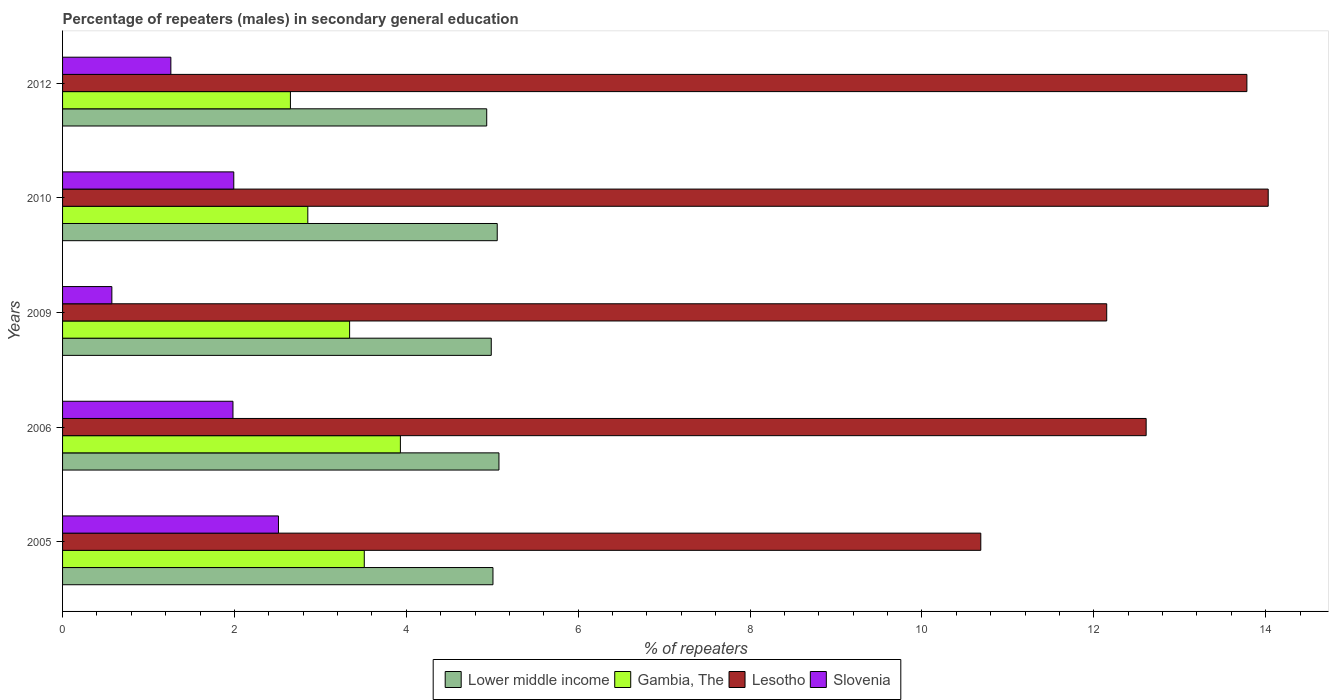How many different coloured bars are there?
Keep it short and to the point. 4. How many groups of bars are there?
Offer a very short reply. 5. Are the number of bars per tick equal to the number of legend labels?
Your answer should be compact. Yes. How many bars are there on the 2nd tick from the bottom?
Your answer should be very brief. 4. What is the label of the 4th group of bars from the top?
Make the answer very short. 2006. In how many cases, is the number of bars for a given year not equal to the number of legend labels?
Your answer should be very brief. 0. What is the percentage of male repeaters in Lesotho in 2006?
Your response must be concise. 12.61. Across all years, what is the maximum percentage of male repeaters in Gambia, The?
Ensure brevity in your answer.  3.93. Across all years, what is the minimum percentage of male repeaters in Lesotho?
Ensure brevity in your answer.  10.68. In which year was the percentage of male repeaters in Lower middle income minimum?
Keep it short and to the point. 2012. What is the total percentage of male repeaters in Lesotho in the graph?
Give a very brief answer. 63.25. What is the difference between the percentage of male repeaters in Lower middle income in 2005 and that in 2010?
Offer a terse response. -0.05. What is the difference between the percentage of male repeaters in Lesotho in 2006 and the percentage of male repeaters in Slovenia in 2009?
Provide a short and direct response. 12.04. What is the average percentage of male repeaters in Gambia, The per year?
Offer a very short reply. 3.26. In the year 2012, what is the difference between the percentage of male repeaters in Slovenia and percentage of male repeaters in Lesotho?
Keep it short and to the point. -12.52. In how many years, is the percentage of male repeaters in Gambia, The greater than 6 %?
Keep it short and to the point. 0. What is the ratio of the percentage of male repeaters in Gambia, The in 2005 to that in 2010?
Ensure brevity in your answer.  1.23. Is the percentage of male repeaters in Gambia, The in 2010 less than that in 2012?
Keep it short and to the point. No. What is the difference between the highest and the second highest percentage of male repeaters in Lesotho?
Provide a succinct answer. 0.25. What is the difference between the highest and the lowest percentage of male repeaters in Gambia, The?
Offer a very short reply. 1.28. In how many years, is the percentage of male repeaters in Gambia, The greater than the average percentage of male repeaters in Gambia, The taken over all years?
Offer a terse response. 3. Is it the case that in every year, the sum of the percentage of male repeaters in Lesotho and percentage of male repeaters in Slovenia is greater than the sum of percentage of male repeaters in Lower middle income and percentage of male repeaters in Gambia, The?
Offer a very short reply. No. What does the 4th bar from the top in 2010 represents?
Ensure brevity in your answer.  Lower middle income. What does the 3rd bar from the bottom in 2010 represents?
Provide a short and direct response. Lesotho. How many bars are there?
Your answer should be very brief. 20. Are all the bars in the graph horizontal?
Give a very brief answer. Yes. How many years are there in the graph?
Offer a terse response. 5. What is the difference between two consecutive major ticks on the X-axis?
Provide a short and direct response. 2. Does the graph contain any zero values?
Offer a terse response. No. Where does the legend appear in the graph?
Provide a short and direct response. Bottom center. How are the legend labels stacked?
Provide a succinct answer. Horizontal. What is the title of the graph?
Provide a short and direct response. Percentage of repeaters (males) in secondary general education. What is the label or title of the X-axis?
Provide a short and direct response. % of repeaters. What is the % of repeaters of Lower middle income in 2005?
Your answer should be very brief. 5.01. What is the % of repeaters in Gambia, The in 2005?
Offer a terse response. 3.51. What is the % of repeaters in Lesotho in 2005?
Your answer should be compact. 10.68. What is the % of repeaters in Slovenia in 2005?
Keep it short and to the point. 2.51. What is the % of repeaters in Lower middle income in 2006?
Your answer should be compact. 5.08. What is the % of repeaters in Gambia, The in 2006?
Give a very brief answer. 3.93. What is the % of repeaters of Lesotho in 2006?
Offer a very short reply. 12.61. What is the % of repeaters in Slovenia in 2006?
Provide a short and direct response. 1.98. What is the % of repeaters of Lower middle income in 2009?
Provide a succinct answer. 4.99. What is the % of repeaters in Gambia, The in 2009?
Ensure brevity in your answer.  3.34. What is the % of repeaters of Lesotho in 2009?
Offer a terse response. 12.15. What is the % of repeaters of Slovenia in 2009?
Offer a terse response. 0.57. What is the % of repeaters of Lower middle income in 2010?
Ensure brevity in your answer.  5.06. What is the % of repeaters in Gambia, The in 2010?
Give a very brief answer. 2.85. What is the % of repeaters of Lesotho in 2010?
Offer a terse response. 14.03. What is the % of repeaters in Slovenia in 2010?
Keep it short and to the point. 1.99. What is the % of repeaters of Lower middle income in 2012?
Your answer should be very brief. 4.94. What is the % of repeaters of Gambia, The in 2012?
Offer a very short reply. 2.65. What is the % of repeaters in Lesotho in 2012?
Provide a succinct answer. 13.78. What is the % of repeaters in Slovenia in 2012?
Offer a terse response. 1.26. Across all years, what is the maximum % of repeaters of Lower middle income?
Give a very brief answer. 5.08. Across all years, what is the maximum % of repeaters in Gambia, The?
Your answer should be compact. 3.93. Across all years, what is the maximum % of repeaters of Lesotho?
Your answer should be very brief. 14.03. Across all years, what is the maximum % of repeaters of Slovenia?
Your answer should be compact. 2.51. Across all years, what is the minimum % of repeaters in Lower middle income?
Keep it short and to the point. 4.94. Across all years, what is the minimum % of repeaters of Gambia, The?
Your answer should be compact. 2.65. Across all years, what is the minimum % of repeaters in Lesotho?
Provide a short and direct response. 10.68. Across all years, what is the minimum % of repeaters of Slovenia?
Your answer should be very brief. 0.57. What is the total % of repeaters in Lower middle income in the graph?
Offer a very short reply. 25.07. What is the total % of repeaters of Gambia, The in the graph?
Ensure brevity in your answer.  16.29. What is the total % of repeaters of Lesotho in the graph?
Ensure brevity in your answer.  63.25. What is the total % of repeaters of Slovenia in the graph?
Provide a short and direct response. 8.32. What is the difference between the % of repeaters of Lower middle income in 2005 and that in 2006?
Offer a terse response. -0.07. What is the difference between the % of repeaters of Gambia, The in 2005 and that in 2006?
Provide a succinct answer. -0.42. What is the difference between the % of repeaters of Lesotho in 2005 and that in 2006?
Keep it short and to the point. -1.92. What is the difference between the % of repeaters of Slovenia in 2005 and that in 2006?
Keep it short and to the point. 0.53. What is the difference between the % of repeaters of Lower middle income in 2005 and that in 2009?
Offer a very short reply. 0.02. What is the difference between the % of repeaters in Gambia, The in 2005 and that in 2009?
Your answer should be compact. 0.17. What is the difference between the % of repeaters of Lesotho in 2005 and that in 2009?
Your response must be concise. -1.47. What is the difference between the % of repeaters in Slovenia in 2005 and that in 2009?
Your answer should be very brief. 1.94. What is the difference between the % of repeaters in Lower middle income in 2005 and that in 2010?
Your response must be concise. -0.05. What is the difference between the % of repeaters in Gambia, The in 2005 and that in 2010?
Make the answer very short. 0.66. What is the difference between the % of repeaters of Lesotho in 2005 and that in 2010?
Keep it short and to the point. -3.34. What is the difference between the % of repeaters in Slovenia in 2005 and that in 2010?
Keep it short and to the point. 0.52. What is the difference between the % of repeaters in Lower middle income in 2005 and that in 2012?
Offer a very short reply. 0.07. What is the difference between the % of repeaters of Gambia, The in 2005 and that in 2012?
Provide a succinct answer. 0.86. What is the difference between the % of repeaters of Lesotho in 2005 and that in 2012?
Your answer should be compact. -3.1. What is the difference between the % of repeaters of Slovenia in 2005 and that in 2012?
Your answer should be compact. 1.25. What is the difference between the % of repeaters of Lower middle income in 2006 and that in 2009?
Ensure brevity in your answer.  0.09. What is the difference between the % of repeaters of Gambia, The in 2006 and that in 2009?
Provide a short and direct response. 0.59. What is the difference between the % of repeaters of Lesotho in 2006 and that in 2009?
Make the answer very short. 0.46. What is the difference between the % of repeaters of Slovenia in 2006 and that in 2009?
Ensure brevity in your answer.  1.41. What is the difference between the % of repeaters in Lower middle income in 2006 and that in 2010?
Provide a succinct answer. 0.02. What is the difference between the % of repeaters of Gambia, The in 2006 and that in 2010?
Keep it short and to the point. 1.08. What is the difference between the % of repeaters of Lesotho in 2006 and that in 2010?
Give a very brief answer. -1.42. What is the difference between the % of repeaters of Slovenia in 2006 and that in 2010?
Make the answer very short. -0.01. What is the difference between the % of repeaters in Lower middle income in 2006 and that in 2012?
Your answer should be very brief. 0.14. What is the difference between the % of repeaters of Gambia, The in 2006 and that in 2012?
Make the answer very short. 1.28. What is the difference between the % of repeaters of Lesotho in 2006 and that in 2012?
Offer a terse response. -1.17. What is the difference between the % of repeaters in Slovenia in 2006 and that in 2012?
Offer a terse response. 0.72. What is the difference between the % of repeaters in Lower middle income in 2009 and that in 2010?
Offer a very short reply. -0.07. What is the difference between the % of repeaters in Gambia, The in 2009 and that in 2010?
Provide a short and direct response. 0.49. What is the difference between the % of repeaters in Lesotho in 2009 and that in 2010?
Make the answer very short. -1.88. What is the difference between the % of repeaters in Slovenia in 2009 and that in 2010?
Your answer should be very brief. -1.42. What is the difference between the % of repeaters of Lower middle income in 2009 and that in 2012?
Your answer should be very brief. 0.05. What is the difference between the % of repeaters in Gambia, The in 2009 and that in 2012?
Keep it short and to the point. 0.69. What is the difference between the % of repeaters of Lesotho in 2009 and that in 2012?
Your response must be concise. -1.63. What is the difference between the % of repeaters in Slovenia in 2009 and that in 2012?
Make the answer very short. -0.69. What is the difference between the % of repeaters of Lower middle income in 2010 and that in 2012?
Give a very brief answer. 0.12. What is the difference between the % of repeaters of Gambia, The in 2010 and that in 2012?
Offer a very short reply. 0.2. What is the difference between the % of repeaters in Lesotho in 2010 and that in 2012?
Keep it short and to the point. 0.25. What is the difference between the % of repeaters in Slovenia in 2010 and that in 2012?
Provide a succinct answer. 0.73. What is the difference between the % of repeaters of Lower middle income in 2005 and the % of repeaters of Gambia, The in 2006?
Make the answer very short. 1.08. What is the difference between the % of repeaters in Lower middle income in 2005 and the % of repeaters in Lesotho in 2006?
Your answer should be compact. -7.6. What is the difference between the % of repeaters in Lower middle income in 2005 and the % of repeaters in Slovenia in 2006?
Offer a very short reply. 3.03. What is the difference between the % of repeaters in Gambia, The in 2005 and the % of repeaters in Lesotho in 2006?
Give a very brief answer. -9.1. What is the difference between the % of repeaters in Gambia, The in 2005 and the % of repeaters in Slovenia in 2006?
Your response must be concise. 1.53. What is the difference between the % of repeaters in Lesotho in 2005 and the % of repeaters in Slovenia in 2006?
Ensure brevity in your answer.  8.7. What is the difference between the % of repeaters of Lower middle income in 2005 and the % of repeaters of Gambia, The in 2009?
Give a very brief answer. 1.67. What is the difference between the % of repeaters of Lower middle income in 2005 and the % of repeaters of Lesotho in 2009?
Your response must be concise. -7.14. What is the difference between the % of repeaters in Lower middle income in 2005 and the % of repeaters in Slovenia in 2009?
Your answer should be very brief. 4.43. What is the difference between the % of repeaters in Gambia, The in 2005 and the % of repeaters in Lesotho in 2009?
Provide a succinct answer. -8.64. What is the difference between the % of repeaters in Gambia, The in 2005 and the % of repeaters in Slovenia in 2009?
Provide a succinct answer. 2.94. What is the difference between the % of repeaters in Lesotho in 2005 and the % of repeaters in Slovenia in 2009?
Your answer should be very brief. 10.11. What is the difference between the % of repeaters of Lower middle income in 2005 and the % of repeaters of Gambia, The in 2010?
Your response must be concise. 2.15. What is the difference between the % of repeaters in Lower middle income in 2005 and the % of repeaters in Lesotho in 2010?
Your response must be concise. -9.02. What is the difference between the % of repeaters in Lower middle income in 2005 and the % of repeaters in Slovenia in 2010?
Offer a very short reply. 3.02. What is the difference between the % of repeaters in Gambia, The in 2005 and the % of repeaters in Lesotho in 2010?
Offer a terse response. -10.52. What is the difference between the % of repeaters of Gambia, The in 2005 and the % of repeaters of Slovenia in 2010?
Your answer should be compact. 1.52. What is the difference between the % of repeaters in Lesotho in 2005 and the % of repeaters in Slovenia in 2010?
Your response must be concise. 8.69. What is the difference between the % of repeaters of Lower middle income in 2005 and the % of repeaters of Gambia, The in 2012?
Ensure brevity in your answer.  2.36. What is the difference between the % of repeaters of Lower middle income in 2005 and the % of repeaters of Lesotho in 2012?
Offer a terse response. -8.77. What is the difference between the % of repeaters of Lower middle income in 2005 and the % of repeaters of Slovenia in 2012?
Give a very brief answer. 3.75. What is the difference between the % of repeaters in Gambia, The in 2005 and the % of repeaters in Lesotho in 2012?
Provide a succinct answer. -10.27. What is the difference between the % of repeaters in Gambia, The in 2005 and the % of repeaters in Slovenia in 2012?
Your answer should be compact. 2.25. What is the difference between the % of repeaters in Lesotho in 2005 and the % of repeaters in Slovenia in 2012?
Offer a terse response. 9.42. What is the difference between the % of repeaters of Lower middle income in 2006 and the % of repeaters of Gambia, The in 2009?
Keep it short and to the point. 1.74. What is the difference between the % of repeaters of Lower middle income in 2006 and the % of repeaters of Lesotho in 2009?
Offer a very short reply. -7.07. What is the difference between the % of repeaters in Lower middle income in 2006 and the % of repeaters in Slovenia in 2009?
Offer a very short reply. 4.5. What is the difference between the % of repeaters of Gambia, The in 2006 and the % of repeaters of Lesotho in 2009?
Offer a terse response. -8.22. What is the difference between the % of repeaters of Gambia, The in 2006 and the % of repeaters of Slovenia in 2009?
Provide a succinct answer. 3.36. What is the difference between the % of repeaters of Lesotho in 2006 and the % of repeaters of Slovenia in 2009?
Make the answer very short. 12.04. What is the difference between the % of repeaters in Lower middle income in 2006 and the % of repeaters in Gambia, The in 2010?
Keep it short and to the point. 2.22. What is the difference between the % of repeaters in Lower middle income in 2006 and the % of repeaters in Lesotho in 2010?
Offer a very short reply. -8.95. What is the difference between the % of repeaters of Lower middle income in 2006 and the % of repeaters of Slovenia in 2010?
Give a very brief answer. 3.09. What is the difference between the % of repeaters of Gambia, The in 2006 and the % of repeaters of Lesotho in 2010?
Keep it short and to the point. -10.1. What is the difference between the % of repeaters of Gambia, The in 2006 and the % of repeaters of Slovenia in 2010?
Give a very brief answer. 1.94. What is the difference between the % of repeaters of Lesotho in 2006 and the % of repeaters of Slovenia in 2010?
Your answer should be very brief. 10.62. What is the difference between the % of repeaters in Lower middle income in 2006 and the % of repeaters in Gambia, The in 2012?
Offer a very short reply. 2.43. What is the difference between the % of repeaters in Lower middle income in 2006 and the % of repeaters in Lesotho in 2012?
Provide a succinct answer. -8.7. What is the difference between the % of repeaters in Lower middle income in 2006 and the % of repeaters in Slovenia in 2012?
Your answer should be very brief. 3.82. What is the difference between the % of repeaters in Gambia, The in 2006 and the % of repeaters in Lesotho in 2012?
Provide a short and direct response. -9.85. What is the difference between the % of repeaters of Gambia, The in 2006 and the % of repeaters of Slovenia in 2012?
Provide a succinct answer. 2.67. What is the difference between the % of repeaters of Lesotho in 2006 and the % of repeaters of Slovenia in 2012?
Your answer should be very brief. 11.35. What is the difference between the % of repeaters in Lower middle income in 2009 and the % of repeaters in Gambia, The in 2010?
Offer a very short reply. 2.13. What is the difference between the % of repeaters in Lower middle income in 2009 and the % of repeaters in Lesotho in 2010?
Offer a very short reply. -9.04. What is the difference between the % of repeaters in Lower middle income in 2009 and the % of repeaters in Slovenia in 2010?
Give a very brief answer. 3. What is the difference between the % of repeaters of Gambia, The in 2009 and the % of repeaters of Lesotho in 2010?
Make the answer very short. -10.69. What is the difference between the % of repeaters in Gambia, The in 2009 and the % of repeaters in Slovenia in 2010?
Your answer should be compact. 1.35. What is the difference between the % of repeaters in Lesotho in 2009 and the % of repeaters in Slovenia in 2010?
Provide a short and direct response. 10.16. What is the difference between the % of repeaters of Lower middle income in 2009 and the % of repeaters of Gambia, The in 2012?
Your answer should be compact. 2.34. What is the difference between the % of repeaters in Lower middle income in 2009 and the % of repeaters in Lesotho in 2012?
Your answer should be compact. -8.79. What is the difference between the % of repeaters of Lower middle income in 2009 and the % of repeaters of Slovenia in 2012?
Offer a very short reply. 3.73. What is the difference between the % of repeaters of Gambia, The in 2009 and the % of repeaters of Lesotho in 2012?
Offer a terse response. -10.44. What is the difference between the % of repeaters of Gambia, The in 2009 and the % of repeaters of Slovenia in 2012?
Keep it short and to the point. 2.08. What is the difference between the % of repeaters of Lesotho in 2009 and the % of repeaters of Slovenia in 2012?
Give a very brief answer. 10.89. What is the difference between the % of repeaters of Lower middle income in 2010 and the % of repeaters of Gambia, The in 2012?
Make the answer very short. 2.41. What is the difference between the % of repeaters of Lower middle income in 2010 and the % of repeaters of Lesotho in 2012?
Make the answer very short. -8.72. What is the difference between the % of repeaters in Lower middle income in 2010 and the % of repeaters in Slovenia in 2012?
Make the answer very short. 3.8. What is the difference between the % of repeaters in Gambia, The in 2010 and the % of repeaters in Lesotho in 2012?
Give a very brief answer. -10.93. What is the difference between the % of repeaters in Gambia, The in 2010 and the % of repeaters in Slovenia in 2012?
Offer a very short reply. 1.59. What is the difference between the % of repeaters of Lesotho in 2010 and the % of repeaters of Slovenia in 2012?
Offer a terse response. 12.77. What is the average % of repeaters of Lower middle income per year?
Ensure brevity in your answer.  5.01. What is the average % of repeaters of Gambia, The per year?
Your answer should be compact. 3.26. What is the average % of repeaters in Lesotho per year?
Offer a terse response. 12.65. What is the average % of repeaters in Slovenia per year?
Make the answer very short. 1.66. In the year 2005, what is the difference between the % of repeaters of Lower middle income and % of repeaters of Gambia, The?
Give a very brief answer. 1.5. In the year 2005, what is the difference between the % of repeaters of Lower middle income and % of repeaters of Lesotho?
Provide a short and direct response. -5.68. In the year 2005, what is the difference between the % of repeaters in Lower middle income and % of repeaters in Slovenia?
Offer a terse response. 2.5. In the year 2005, what is the difference between the % of repeaters in Gambia, The and % of repeaters in Lesotho?
Your answer should be compact. -7.17. In the year 2005, what is the difference between the % of repeaters in Gambia, The and % of repeaters in Slovenia?
Your response must be concise. 1. In the year 2005, what is the difference between the % of repeaters in Lesotho and % of repeaters in Slovenia?
Your response must be concise. 8.17. In the year 2006, what is the difference between the % of repeaters in Lower middle income and % of repeaters in Gambia, The?
Ensure brevity in your answer.  1.15. In the year 2006, what is the difference between the % of repeaters in Lower middle income and % of repeaters in Lesotho?
Provide a succinct answer. -7.53. In the year 2006, what is the difference between the % of repeaters of Lower middle income and % of repeaters of Slovenia?
Give a very brief answer. 3.1. In the year 2006, what is the difference between the % of repeaters in Gambia, The and % of repeaters in Lesotho?
Your answer should be very brief. -8.68. In the year 2006, what is the difference between the % of repeaters in Gambia, The and % of repeaters in Slovenia?
Provide a short and direct response. 1.95. In the year 2006, what is the difference between the % of repeaters in Lesotho and % of repeaters in Slovenia?
Offer a very short reply. 10.63. In the year 2009, what is the difference between the % of repeaters of Lower middle income and % of repeaters of Gambia, The?
Give a very brief answer. 1.65. In the year 2009, what is the difference between the % of repeaters in Lower middle income and % of repeaters in Lesotho?
Make the answer very short. -7.16. In the year 2009, what is the difference between the % of repeaters of Lower middle income and % of repeaters of Slovenia?
Provide a short and direct response. 4.41. In the year 2009, what is the difference between the % of repeaters of Gambia, The and % of repeaters of Lesotho?
Your answer should be very brief. -8.81. In the year 2009, what is the difference between the % of repeaters of Gambia, The and % of repeaters of Slovenia?
Offer a terse response. 2.77. In the year 2009, what is the difference between the % of repeaters of Lesotho and % of repeaters of Slovenia?
Offer a very short reply. 11.58. In the year 2010, what is the difference between the % of repeaters in Lower middle income and % of repeaters in Gambia, The?
Provide a succinct answer. 2.2. In the year 2010, what is the difference between the % of repeaters of Lower middle income and % of repeaters of Lesotho?
Your answer should be very brief. -8.97. In the year 2010, what is the difference between the % of repeaters of Lower middle income and % of repeaters of Slovenia?
Your response must be concise. 3.07. In the year 2010, what is the difference between the % of repeaters of Gambia, The and % of repeaters of Lesotho?
Offer a terse response. -11.18. In the year 2010, what is the difference between the % of repeaters in Gambia, The and % of repeaters in Slovenia?
Give a very brief answer. 0.86. In the year 2010, what is the difference between the % of repeaters in Lesotho and % of repeaters in Slovenia?
Provide a short and direct response. 12.04. In the year 2012, what is the difference between the % of repeaters in Lower middle income and % of repeaters in Gambia, The?
Your answer should be compact. 2.28. In the year 2012, what is the difference between the % of repeaters of Lower middle income and % of repeaters of Lesotho?
Your answer should be very brief. -8.85. In the year 2012, what is the difference between the % of repeaters of Lower middle income and % of repeaters of Slovenia?
Provide a succinct answer. 3.68. In the year 2012, what is the difference between the % of repeaters in Gambia, The and % of repeaters in Lesotho?
Give a very brief answer. -11.13. In the year 2012, what is the difference between the % of repeaters in Gambia, The and % of repeaters in Slovenia?
Offer a very short reply. 1.39. In the year 2012, what is the difference between the % of repeaters of Lesotho and % of repeaters of Slovenia?
Provide a short and direct response. 12.52. What is the ratio of the % of repeaters in Lower middle income in 2005 to that in 2006?
Your answer should be compact. 0.99. What is the ratio of the % of repeaters in Gambia, The in 2005 to that in 2006?
Offer a terse response. 0.89. What is the ratio of the % of repeaters of Lesotho in 2005 to that in 2006?
Provide a succinct answer. 0.85. What is the ratio of the % of repeaters in Slovenia in 2005 to that in 2006?
Your response must be concise. 1.27. What is the ratio of the % of repeaters of Gambia, The in 2005 to that in 2009?
Offer a terse response. 1.05. What is the ratio of the % of repeaters of Lesotho in 2005 to that in 2009?
Offer a very short reply. 0.88. What is the ratio of the % of repeaters in Slovenia in 2005 to that in 2009?
Provide a short and direct response. 4.38. What is the ratio of the % of repeaters in Lower middle income in 2005 to that in 2010?
Your answer should be very brief. 0.99. What is the ratio of the % of repeaters in Gambia, The in 2005 to that in 2010?
Give a very brief answer. 1.23. What is the ratio of the % of repeaters in Lesotho in 2005 to that in 2010?
Offer a very short reply. 0.76. What is the ratio of the % of repeaters in Slovenia in 2005 to that in 2010?
Your answer should be compact. 1.26. What is the ratio of the % of repeaters of Lower middle income in 2005 to that in 2012?
Your answer should be very brief. 1.01. What is the ratio of the % of repeaters in Gambia, The in 2005 to that in 2012?
Your answer should be very brief. 1.32. What is the ratio of the % of repeaters of Lesotho in 2005 to that in 2012?
Offer a very short reply. 0.78. What is the ratio of the % of repeaters in Slovenia in 2005 to that in 2012?
Ensure brevity in your answer.  1.99. What is the ratio of the % of repeaters in Lower middle income in 2006 to that in 2009?
Make the answer very short. 1.02. What is the ratio of the % of repeaters in Gambia, The in 2006 to that in 2009?
Keep it short and to the point. 1.18. What is the ratio of the % of repeaters in Lesotho in 2006 to that in 2009?
Your response must be concise. 1.04. What is the ratio of the % of repeaters of Slovenia in 2006 to that in 2009?
Offer a very short reply. 3.46. What is the ratio of the % of repeaters of Gambia, The in 2006 to that in 2010?
Make the answer very short. 1.38. What is the ratio of the % of repeaters in Lesotho in 2006 to that in 2010?
Provide a succinct answer. 0.9. What is the ratio of the % of repeaters of Slovenia in 2006 to that in 2010?
Offer a very short reply. 1. What is the ratio of the % of repeaters in Lower middle income in 2006 to that in 2012?
Give a very brief answer. 1.03. What is the ratio of the % of repeaters of Gambia, The in 2006 to that in 2012?
Keep it short and to the point. 1.48. What is the ratio of the % of repeaters of Lesotho in 2006 to that in 2012?
Make the answer very short. 0.91. What is the ratio of the % of repeaters of Slovenia in 2006 to that in 2012?
Provide a short and direct response. 1.57. What is the ratio of the % of repeaters in Lower middle income in 2009 to that in 2010?
Provide a succinct answer. 0.99. What is the ratio of the % of repeaters of Gambia, The in 2009 to that in 2010?
Your response must be concise. 1.17. What is the ratio of the % of repeaters in Lesotho in 2009 to that in 2010?
Ensure brevity in your answer.  0.87. What is the ratio of the % of repeaters in Slovenia in 2009 to that in 2010?
Offer a terse response. 0.29. What is the ratio of the % of repeaters of Lower middle income in 2009 to that in 2012?
Give a very brief answer. 1.01. What is the ratio of the % of repeaters in Gambia, The in 2009 to that in 2012?
Offer a very short reply. 1.26. What is the ratio of the % of repeaters in Lesotho in 2009 to that in 2012?
Ensure brevity in your answer.  0.88. What is the ratio of the % of repeaters of Slovenia in 2009 to that in 2012?
Keep it short and to the point. 0.46. What is the ratio of the % of repeaters of Lower middle income in 2010 to that in 2012?
Offer a very short reply. 1.02. What is the ratio of the % of repeaters in Gambia, The in 2010 to that in 2012?
Offer a very short reply. 1.08. What is the ratio of the % of repeaters in Lesotho in 2010 to that in 2012?
Keep it short and to the point. 1.02. What is the ratio of the % of repeaters of Slovenia in 2010 to that in 2012?
Provide a succinct answer. 1.58. What is the difference between the highest and the second highest % of repeaters in Gambia, The?
Provide a succinct answer. 0.42. What is the difference between the highest and the second highest % of repeaters of Lesotho?
Your response must be concise. 0.25. What is the difference between the highest and the second highest % of repeaters of Slovenia?
Your response must be concise. 0.52. What is the difference between the highest and the lowest % of repeaters of Lower middle income?
Offer a very short reply. 0.14. What is the difference between the highest and the lowest % of repeaters of Gambia, The?
Provide a succinct answer. 1.28. What is the difference between the highest and the lowest % of repeaters of Lesotho?
Provide a short and direct response. 3.34. What is the difference between the highest and the lowest % of repeaters in Slovenia?
Your answer should be very brief. 1.94. 